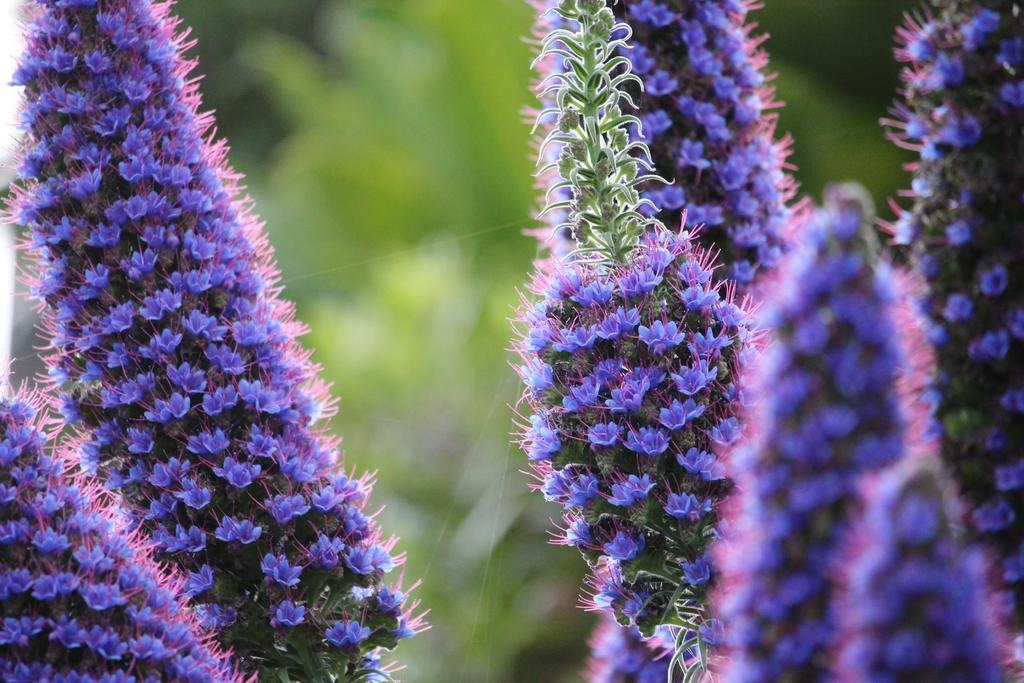What type of living organisms can be seen in the image? Plants can be seen in the image. What specific features do the plants have? The plants have flowers, leaves, and buds. What color are the flowers in the image? The flowers are in violet color. Are there any plants in the background of the image? Yes, there are plants in the background of the image. What type of bean is being discussed in the image? There is no bean or discussion present in the image; it features plants with flowers, leaves, and buds. 